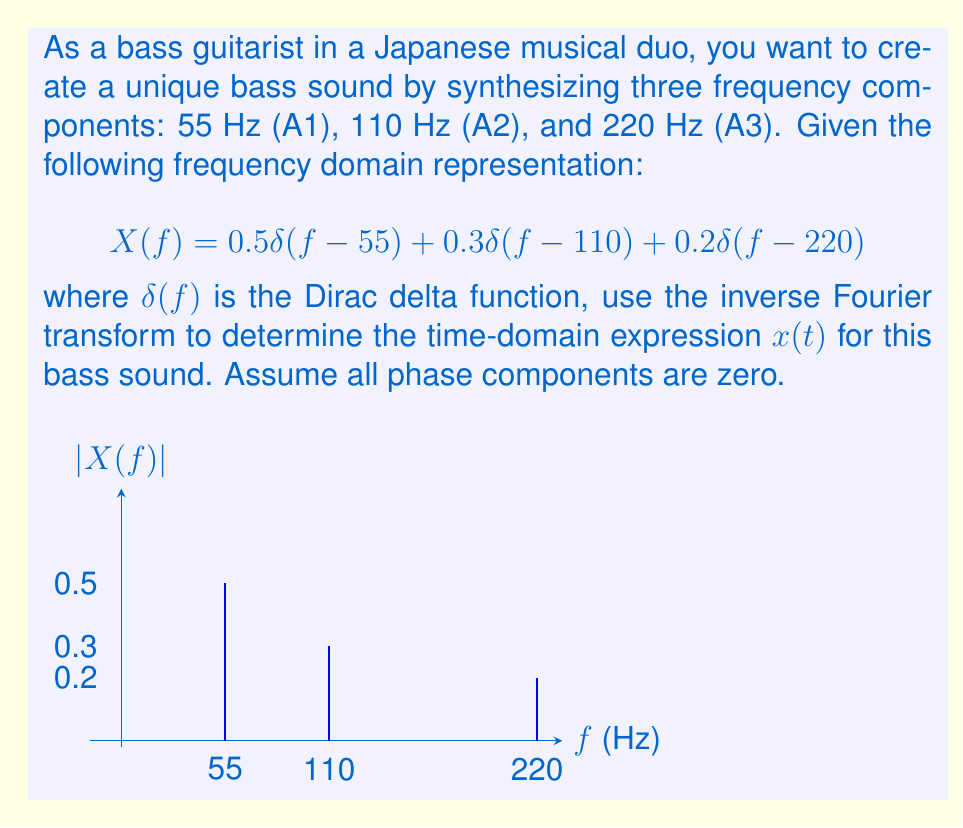Give your solution to this math problem. To solve this problem, we'll use the inverse Fourier transform formula:

$$x(t) = \int_{-\infty}^{\infty} X(f) e^{j2\pi ft} df$$

Given the frequency domain representation:

$$X(f) = 0.5\delta(f-55) + 0.3\delta(f-110) + 0.2\delta(f-220)$$

Step 1: Apply the inverse Fourier transform:
$$x(t) = \int_{-\infty}^{\infty} [0.5\delta(f-55) + 0.3\delta(f-110) + 0.2\delta(f-220)] e^{j2\pi ft} df$$

Step 2: Use the sifting property of the delta function:
$$x(t) = 0.5e^{j2\pi(55)t} + 0.3e^{j2\pi(110)t} + 0.2e^{j2\pi(220)t}$$

Step 3: Since all phase components are zero, we can replace $e^{j\theta}$ with $\cos(\theta)$:
$$x(t) = 0.5\cos(2\pi(55)t) + 0.3\cos(2\pi(110)t) + 0.2\cos(2\pi(220)t)$$

Step 4: Simplify by factoring out $2\pi$:
$$x(t) = 0.5\cos(110\pi t) + 0.3\cos(220\pi t) + 0.2\cos(440\pi t)$$

This expression represents the time-domain signal of the unique bass sound, composed of three harmonic components with different amplitudes.
Answer: $x(t) = 0.5\cos(110\pi t) + 0.3\cos(220\pi t) + 0.2\cos(440\pi t)$ 